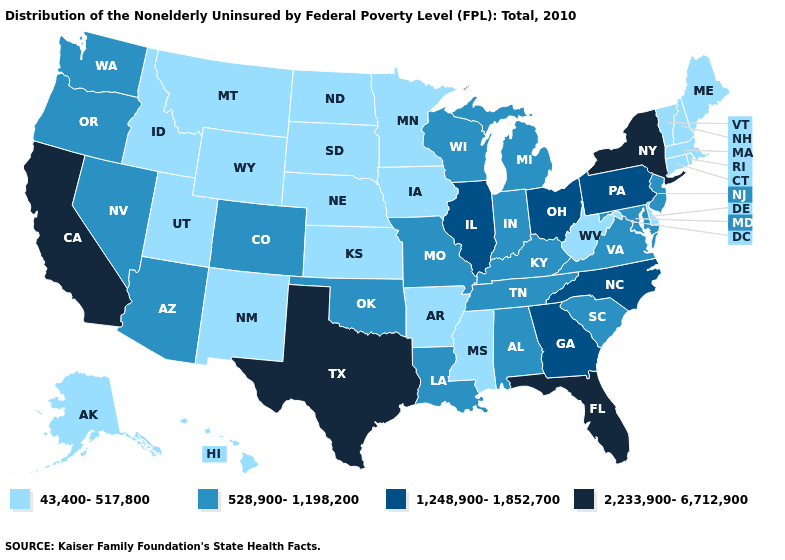What is the value of Vermont?
Short answer required. 43,400-517,800. Is the legend a continuous bar?
Be succinct. No. Among the states that border Pennsylvania , which have the highest value?
Keep it brief. New York. What is the value of Mississippi?
Give a very brief answer. 43,400-517,800. What is the lowest value in states that border Virginia?
Short answer required. 43,400-517,800. What is the lowest value in states that border Pennsylvania?
Concise answer only. 43,400-517,800. Name the states that have a value in the range 2,233,900-6,712,900?
Short answer required. California, Florida, New York, Texas. Name the states that have a value in the range 1,248,900-1,852,700?
Write a very short answer. Georgia, Illinois, North Carolina, Ohio, Pennsylvania. What is the value of Oklahoma?
Be succinct. 528,900-1,198,200. Among the states that border Florida , does Alabama have the highest value?
Answer briefly. No. Name the states that have a value in the range 43,400-517,800?
Give a very brief answer. Alaska, Arkansas, Connecticut, Delaware, Hawaii, Idaho, Iowa, Kansas, Maine, Massachusetts, Minnesota, Mississippi, Montana, Nebraska, New Hampshire, New Mexico, North Dakota, Rhode Island, South Dakota, Utah, Vermont, West Virginia, Wyoming. Name the states that have a value in the range 2,233,900-6,712,900?
Quick response, please. California, Florida, New York, Texas. Among the states that border Vermont , does New Hampshire have the highest value?
Write a very short answer. No. How many symbols are there in the legend?
Give a very brief answer. 4. 